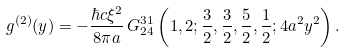<formula> <loc_0><loc_0><loc_500><loc_500>g ^ { ( 2 ) } ( y ) = - \frac { \hbar { c } { \xi } ^ { 2 } } { 8 \pi a } \, G ^ { 3 1 } _ { 2 4 } \left ( 1 , 2 ; \frac { 3 } { 2 } , \frac { 3 } { 2 } , \frac { 5 } { 2 } , \frac { 1 } { 2 } ; 4 a ^ { 2 } y ^ { 2 } \right ) .</formula> 